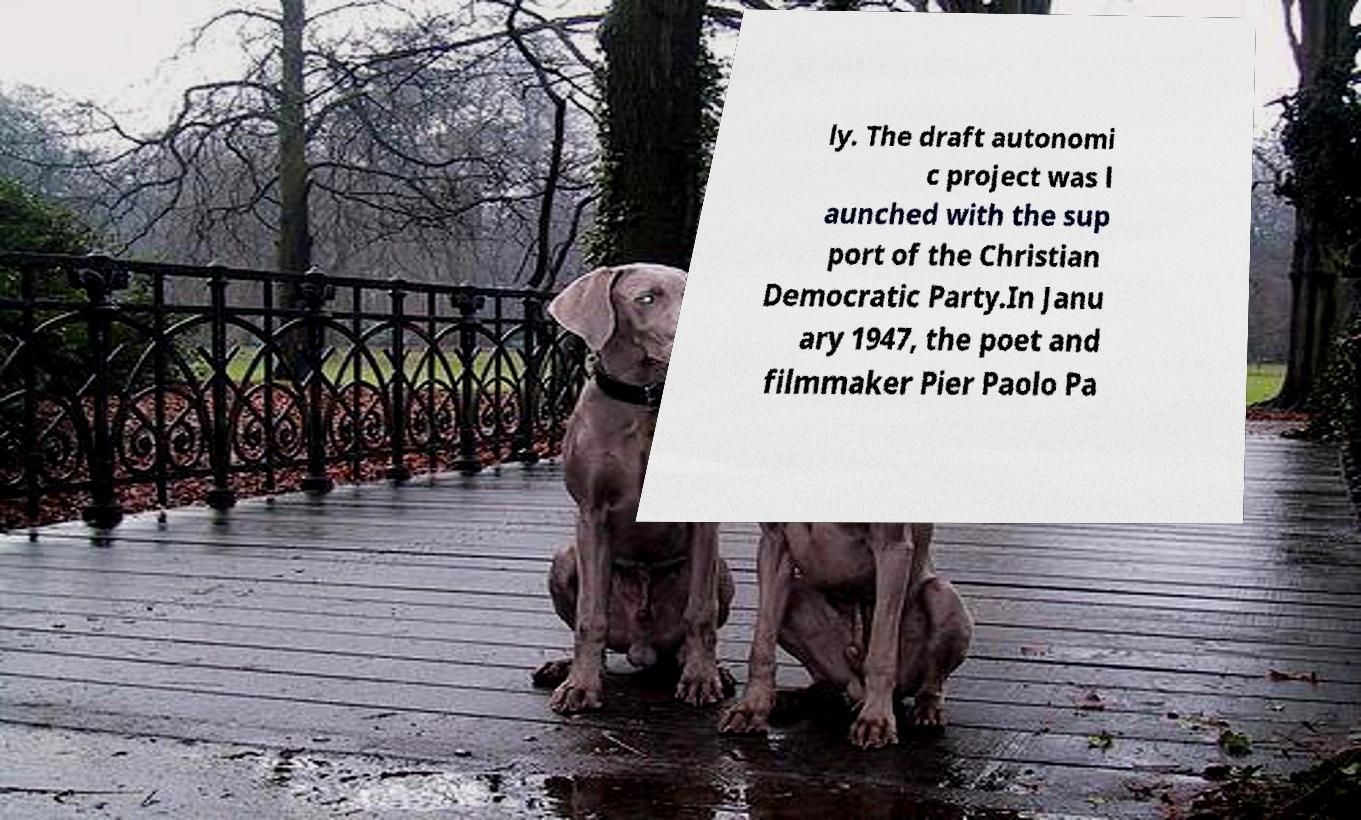For documentation purposes, I need the text within this image transcribed. Could you provide that? ly. The draft autonomi c project was l aunched with the sup port of the Christian Democratic Party.In Janu ary 1947, the poet and filmmaker Pier Paolo Pa 